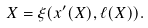<formula> <loc_0><loc_0><loc_500><loc_500>X = \xi ( x ^ { \prime } ( X ) , \ell ( X ) ) .</formula> 